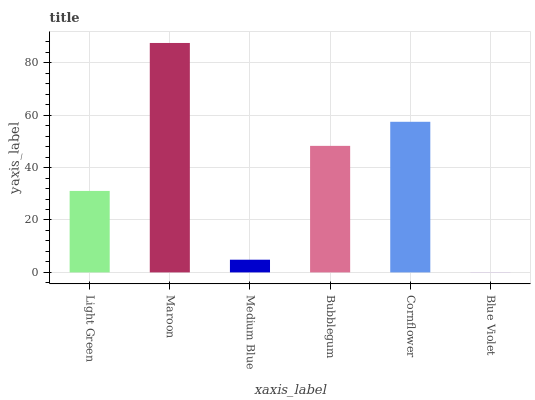Is Blue Violet the minimum?
Answer yes or no. Yes. Is Maroon the maximum?
Answer yes or no. Yes. Is Medium Blue the minimum?
Answer yes or no. No. Is Medium Blue the maximum?
Answer yes or no. No. Is Maroon greater than Medium Blue?
Answer yes or no. Yes. Is Medium Blue less than Maroon?
Answer yes or no. Yes. Is Medium Blue greater than Maroon?
Answer yes or no. No. Is Maroon less than Medium Blue?
Answer yes or no. No. Is Bubblegum the high median?
Answer yes or no. Yes. Is Light Green the low median?
Answer yes or no. Yes. Is Medium Blue the high median?
Answer yes or no. No. Is Medium Blue the low median?
Answer yes or no. No. 